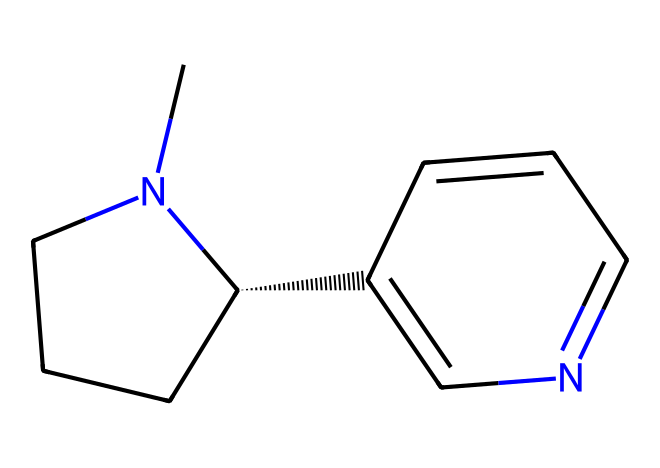What is the molecular formula of nicotine? To determine the molecular formula of nicotine from the SMILES representation, we can count the carbon (C), hydrogen (H), and nitrogen (N) atoms present in the structure. The structure shows 10 carbon atoms, 14 hydrogen atoms, and 2 nitrogen atoms, leading to the formula C10H14N2.
Answer: C10H14N2 How many rings are present in the nicotine structure? Analyzing the structure from the SMILES, we can identify two distinct ring systems within the molecule: one piperidine ring and one pyridine ring, which indicates that there are a total of two rings present in the structure.
Answer: 2 What type of compound is nicotine classified as? Reviewing the presence of nitrogen and the aromatic nature implied by the pyridine component, we can conclude that nicotine is classified as an alkaloid, which is a nitrogen-containing organic compound, usually derived from plants.
Answer: alkaloid How many nitrogen atoms are in the structure? By visual inspection of the SMILES representation, we count two distinct nitrogen atoms that contribute to the overall structural framework of nicotine.
Answer: 2 What functional groups are present in nicotine? The primary functional groups in nicotine include the pyridine ring and the piperidine ring, as both contribute to the overall properties of the compound, defining it as an aromatic and heterocyclic compound.
Answer: pyridine and piperidine rings Is nicotine considered a lipophilic compound? Given the hydrocarbon nature of the carbon and hydrogen components, alongside the aromatic characteristics and the relative lack of polar functional groups, we can deduce that nicotine has lipophilic (fat-loving) characteristics, enabling it to readily interact with lipid membranes.
Answer: yes 